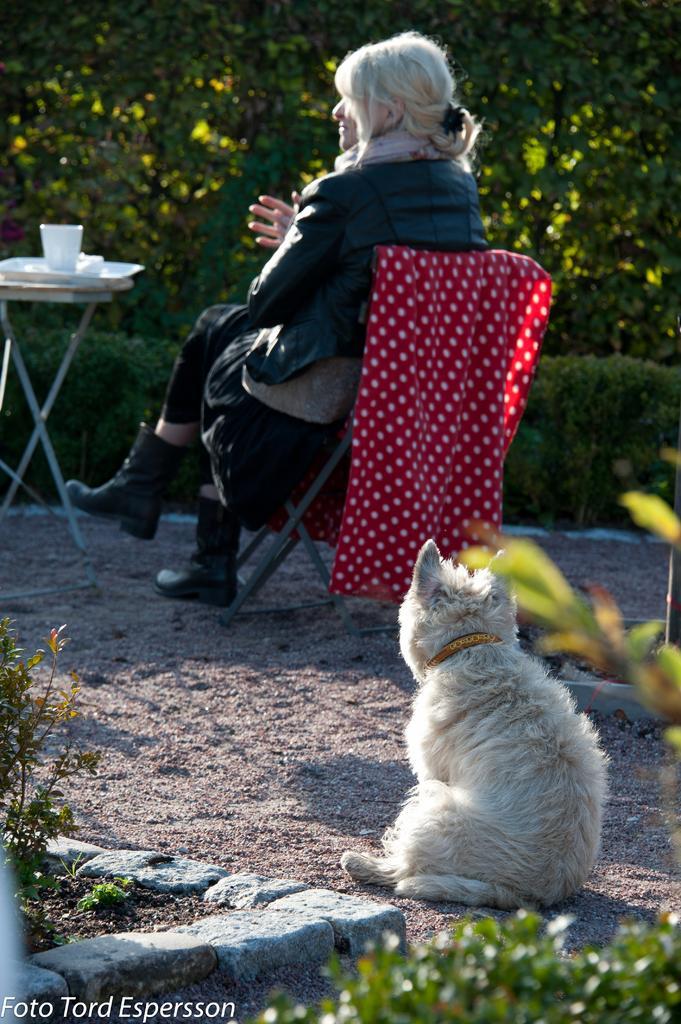In one or two sentences, can you explain what this image depicts? There is a woman sitting on a chair. This is a cat. At the left corner of the image there is a small table with a plate and cup placed on it. Red cloth is hanged on the chair. At background I can see trees and bushes. 